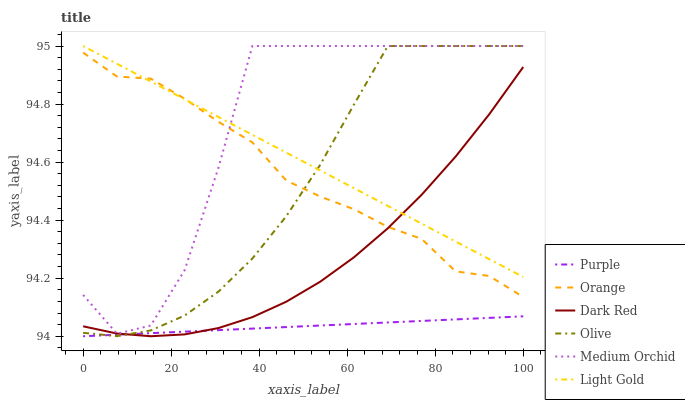Does Purple have the minimum area under the curve?
Answer yes or no. Yes. Does Medium Orchid have the maximum area under the curve?
Answer yes or no. Yes. Does Dark Red have the minimum area under the curve?
Answer yes or no. No. Does Dark Red have the maximum area under the curve?
Answer yes or no. No. Is Purple the smoothest?
Answer yes or no. Yes. Is Medium Orchid the roughest?
Answer yes or no. Yes. Is Dark Red the smoothest?
Answer yes or no. No. Is Dark Red the roughest?
Answer yes or no. No. Does Purple have the lowest value?
Answer yes or no. Yes. Does Dark Red have the lowest value?
Answer yes or no. No. Does Light Gold have the highest value?
Answer yes or no. Yes. Does Dark Red have the highest value?
Answer yes or no. No. Is Purple less than Light Gold?
Answer yes or no. Yes. Is Orange greater than Purple?
Answer yes or no. Yes. Does Olive intersect Light Gold?
Answer yes or no. Yes. Is Olive less than Light Gold?
Answer yes or no. No. Is Olive greater than Light Gold?
Answer yes or no. No. Does Purple intersect Light Gold?
Answer yes or no. No. 